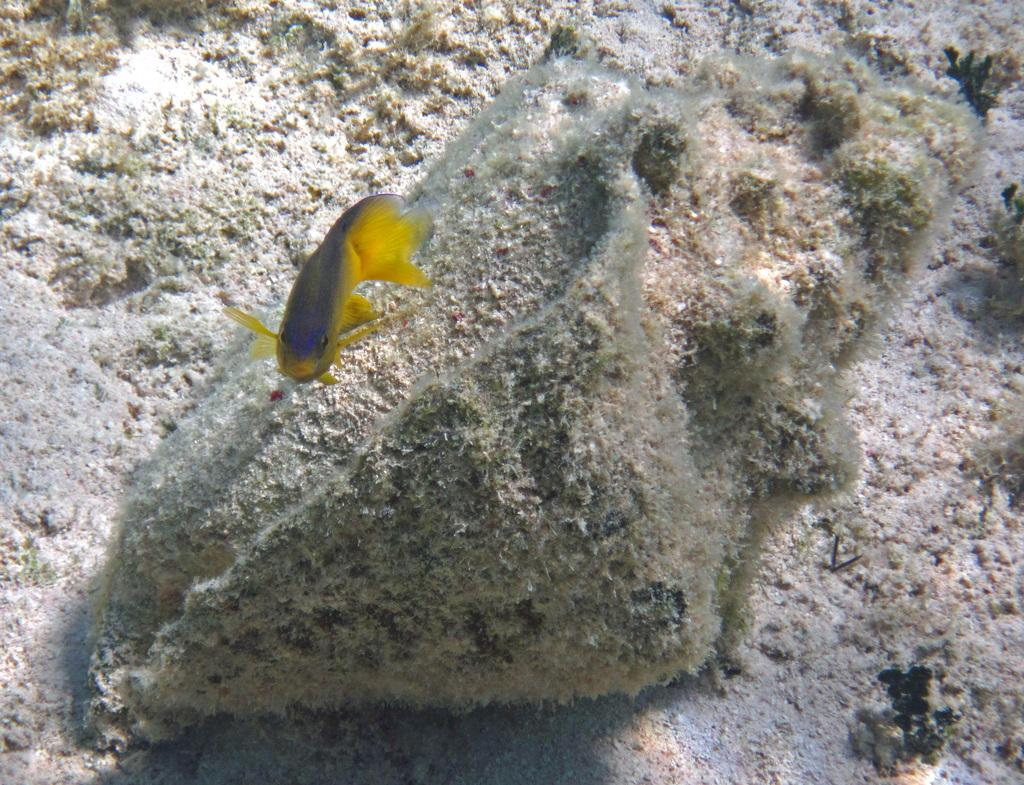What type of animal is present in the image? There is a fish in the image. What government policy is being discussed in the image? There is no discussion or reference to any government policy in the image, as it only features a fish. 